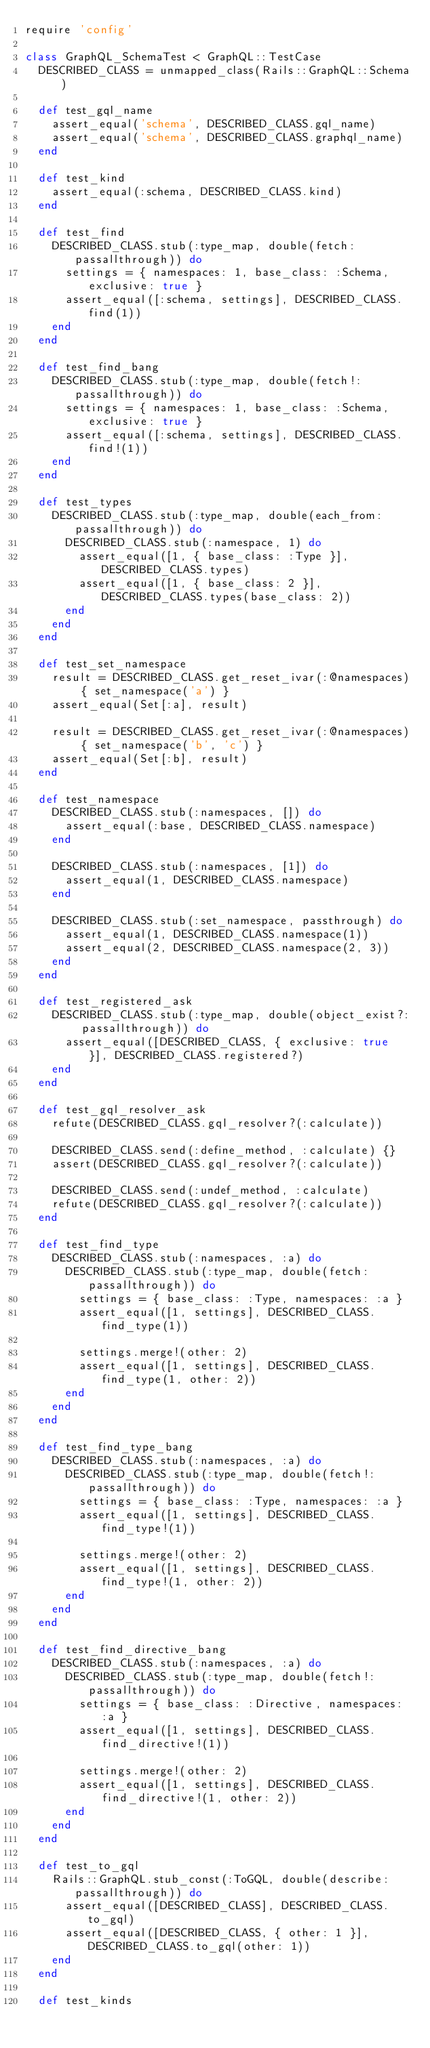<code> <loc_0><loc_0><loc_500><loc_500><_Ruby_>require 'config'

class GraphQL_SchemaTest < GraphQL::TestCase
  DESCRIBED_CLASS = unmapped_class(Rails::GraphQL::Schema)

  def test_gql_name
    assert_equal('schema', DESCRIBED_CLASS.gql_name)
    assert_equal('schema', DESCRIBED_CLASS.graphql_name)
  end

  def test_kind
    assert_equal(:schema, DESCRIBED_CLASS.kind)
  end

  def test_find
    DESCRIBED_CLASS.stub(:type_map, double(fetch: passallthrough)) do
      settings = { namespaces: 1, base_class: :Schema, exclusive: true }
      assert_equal([:schema, settings], DESCRIBED_CLASS.find(1))
    end
  end

  def test_find_bang
    DESCRIBED_CLASS.stub(:type_map, double(fetch!: passallthrough)) do
      settings = { namespaces: 1, base_class: :Schema, exclusive: true }
      assert_equal([:schema, settings], DESCRIBED_CLASS.find!(1))
    end
  end

  def test_types
    DESCRIBED_CLASS.stub(:type_map, double(each_from: passallthrough)) do
      DESCRIBED_CLASS.stub(:namespace, 1) do
        assert_equal([1, { base_class: :Type }], DESCRIBED_CLASS.types)
        assert_equal([1, { base_class: 2 }], DESCRIBED_CLASS.types(base_class: 2))
      end
    end
  end

  def test_set_namespace
    result = DESCRIBED_CLASS.get_reset_ivar(:@namespaces) { set_namespace('a') }
    assert_equal(Set[:a], result)

    result = DESCRIBED_CLASS.get_reset_ivar(:@namespaces) { set_namespace('b', 'c') }
    assert_equal(Set[:b], result)
  end

  def test_namespace
    DESCRIBED_CLASS.stub(:namespaces, []) do
      assert_equal(:base, DESCRIBED_CLASS.namespace)
    end

    DESCRIBED_CLASS.stub(:namespaces, [1]) do
      assert_equal(1, DESCRIBED_CLASS.namespace)
    end

    DESCRIBED_CLASS.stub(:set_namespace, passthrough) do
      assert_equal(1, DESCRIBED_CLASS.namespace(1))
      assert_equal(2, DESCRIBED_CLASS.namespace(2, 3))
    end
  end

  def test_registered_ask
    DESCRIBED_CLASS.stub(:type_map, double(object_exist?: passallthrough)) do
      assert_equal([DESCRIBED_CLASS, { exclusive: true }], DESCRIBED_CLASS.registered?)
    end
  end

  def test_gql_resolver_ask
    refute(DESCRIBED_CLASS.gql_resolver?(:calculate))

    DESCRIBED_CLASS.send(:define_method, :calculate) {}
    assert(DESCRIBED_CLASS.gql_resolver?(:calculate))

    DESCRIBED_CLASS.send(:undef_method, :calculate)
    refute(DESCRIBED_CLASS.gql_resolver?(:calculate))
  end

  def test_find_type
    DESCRIBED_CLASS.stub(:namespaces, :a) do
      DESCRIBED_CLASS.stub(:type_map, double(fetch: passallthrough)) do
        settings = { base_class: :Type, namespaces: :a }
        assert_equal([1, settings], DESCRIBED_CLASS.find_type(1))

        settings.merge!(other: 2)
        assert_equal([1, settings], DESCRIBED_CLASS.find_type(1, other: 2))
      end
    end
  end

  def test_find_type_bang
    DESCRIBED_CLASS.stub(:namespaces, :a) do
      DESCRIBED_CLASS.stub(:type_map, double(fetch!: passallthrough)) do
        settings = { base_class: :Type, namespaces: :a }
        assert_equal([1, settings], DESCRIBED_CLASS.find_type!(1))

        settings.merge!(other: 2)
        assert_equal([1, settings], DESCRIBED_CLASS.find_type!(1, other: 2))
      end
    end
  end

  def test_find_directive_bang
    DESCRIBED_CLASS.stub(:namespaces, :a) do
      DESCRIBED_CLASS.stub(:type_map, double(fetch!: passallthrough)) do
        settings = { base_class: :Directive, namespaces: :a }
        assert_equal([1, settings], DESCRIBED_CLASS.find_directive!(1))

        settings.merge!(other: 2)
        assert_equal([1, settings], DESCRIBED_CLASS.find_directive!(1, other: 2))
      end
    end
  end

  def test_to_gql
    Rails::GraphQL.stub_const(:ToGQL, double(describe: passallthrough)) do
      assert_equal([DESCRIBED_CLASS], DESCRIBED_CLASS.to_gql)
      assert_equal([DESCRIBED_CLASS, { other: 1 }], DESCRIBED_CLASS.to_gql(other: 1))
    end
  end

  def test_kinds</code> 